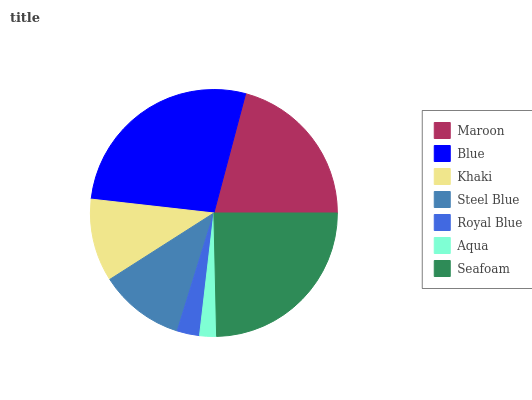Is Aqua the minimum?
Answer yes or no. Yes. Is Blue the maximum?
Answer yes or no. Yes. Is Khaki the minimum?
Answer yes or no. No. Is Khaki the maximum?
Answer yes or no. No. Is Blue greater than Khaki?
Answer yes or no. Yes. Is Khaki less than Blue?
Answer yes or no. Yes. Is Khaki greater than Blue?
Answer yes or no. No. Is Blue less than Khaki?
Answer yes or no. No. Is Steel Blue the high median?
Answer yes or no. Yes. Is Steel Blue the low median?
Answer yes or no. Yes. Is Seafoam the high median?
Answer yes or no. No. Is Aqua the low median?
Answer yes or no. No. 